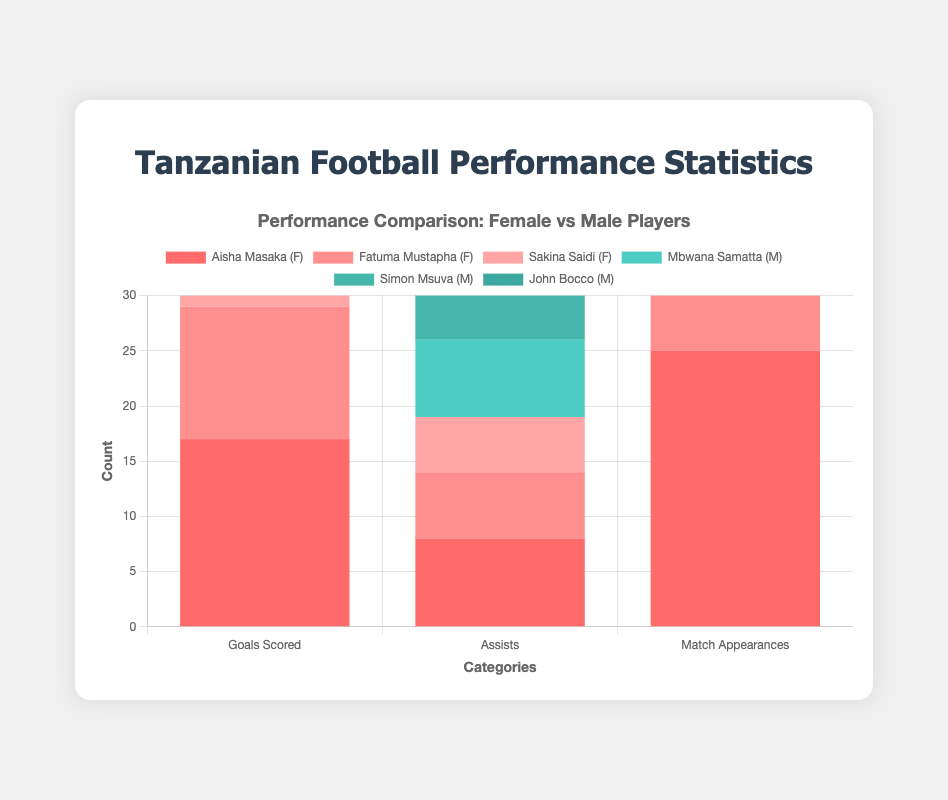Which male player has the highest number of match appearances? By looking at the bar heights for match appearances, we can see that Mbwana Samatta has the tallest bar among the male players.
Answer: Mbwana Samatta Who has more assists, Aisha Masaka or Mbwana Samatta? Compare the bar heights for assists for both players. Aisha Masaka's bar is higher than Mbwana Samatta's.
Answer: Aisha Masaka What is the total number of goals scored by all female players? Sum the goals scored by Aisha Masaka (17), Fatuma Mustapha (12), and Sakina Saidi (9): 17 + 12 + 9.
Answer: 38 How many more match appearances does Aisha Masaka have than Fatuma Mustapha? Subtract the number of match appearances for Fatuma Mustapha from Aisha Masaka's total: 25 - 20.
Answer: 5 Which player, male or female, has the highest number of assists in total? Compare the tallest assist bars for male and female players. Aisha Masaka has the highest with 8 assists.
Answer: Aisha Masaka What is the difference in goals scored between Mbwana Samatta and Simon Msuva? Subtract Simon Msuva's goals from Mbwana Samatta's: 20 - 15.
Answer: 5 How does the total number of match appearances for male players compare with female players? Sum the match appearances for male players (27 + 22 + 19 = 68) and female players (25 + 20 + 18 = 63). Compare both sums.
Answer: Males: 68, Females: 63 Which category (goals scored, assists, or match appearances) has the largest difference between Mbwana Samatta and Aisha Masaka? Calculate the differences in each category: Goals (20 - 17 = 3), Assists (7 - 8 = -1), Match Appearances (27 - 25 = 2). The largest difference is in Goals (3).
Answer: Goals Scored Who has the higher total combined score for goals and assists, Aisha Masaka or John Bocco? Calculate the combined score for each player: Aisha Masaka (17 + 8 = 25) and John Bocco (10 + 4 = 14). Aisha Masaka has a higher total.
Answer: Aisha Masaka What is the average number of goals scored by female players? Sum the goals scored by female players (17 + 12 + 9 = 38) and divide by the number of players (3): 38 / 3.
Answer: 12.67 